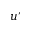<formula> <loc_0><loc_0><loc_500><loc_500>u ^ { \prime }</formula> 